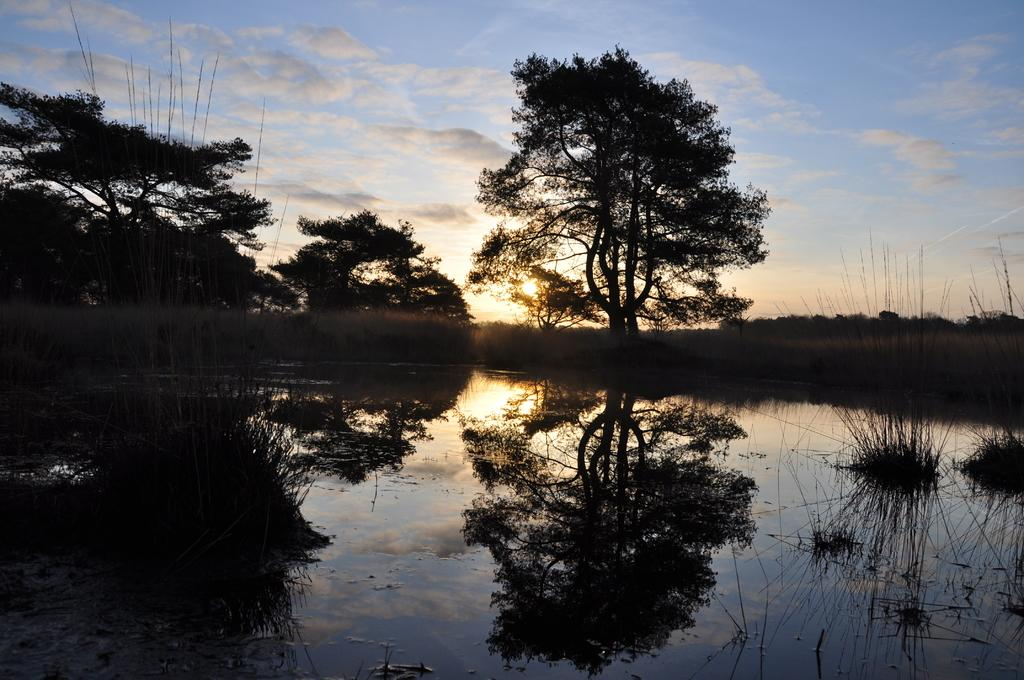What is located at the bottom of the image? There is a pond at the bottom of the image. What can be seen in the middle of the image? There are trees in the middle of the image. What is visible at the top of the image? The sky is visible at the top of the image. How would you describe the sky in the image? The sky appears to be cloudy. What type of test is being conducted by the parent in the image? There is no parent or test present in the image. How does the coach instruct the players in the image? There is no coach or players present in the image. 